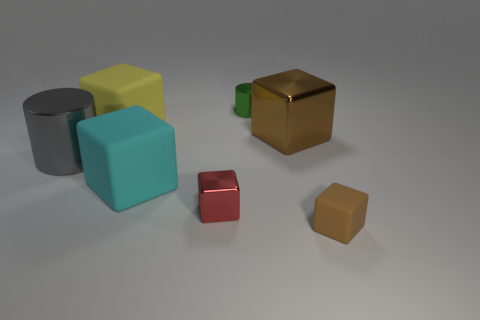Add 3 cylinders. How many objects exist? 10 Subtract all big yellow blocks. How many blocks are left? 4 Subtract 0 yellow spheres. How many objects are left? 7 Subtract all cubes. How many objects are left? 2 Subtract 2 cylinders. How many cylinders are left? 0 Subtract all gray blocks. Subtract all brown cylinders. How many blocks are left? 5 Subtract all brown cylinders. How many brown blocks are left? 2 Subtract all small brown blocks. Subtract all large metal cylinders. How many objects are left? 5 Add 1 tiny metal objects. How many tiny metal objects are left? 3 Add 2 large yellow rubber blocks. How many large yellow rubber blocks exist? 3 